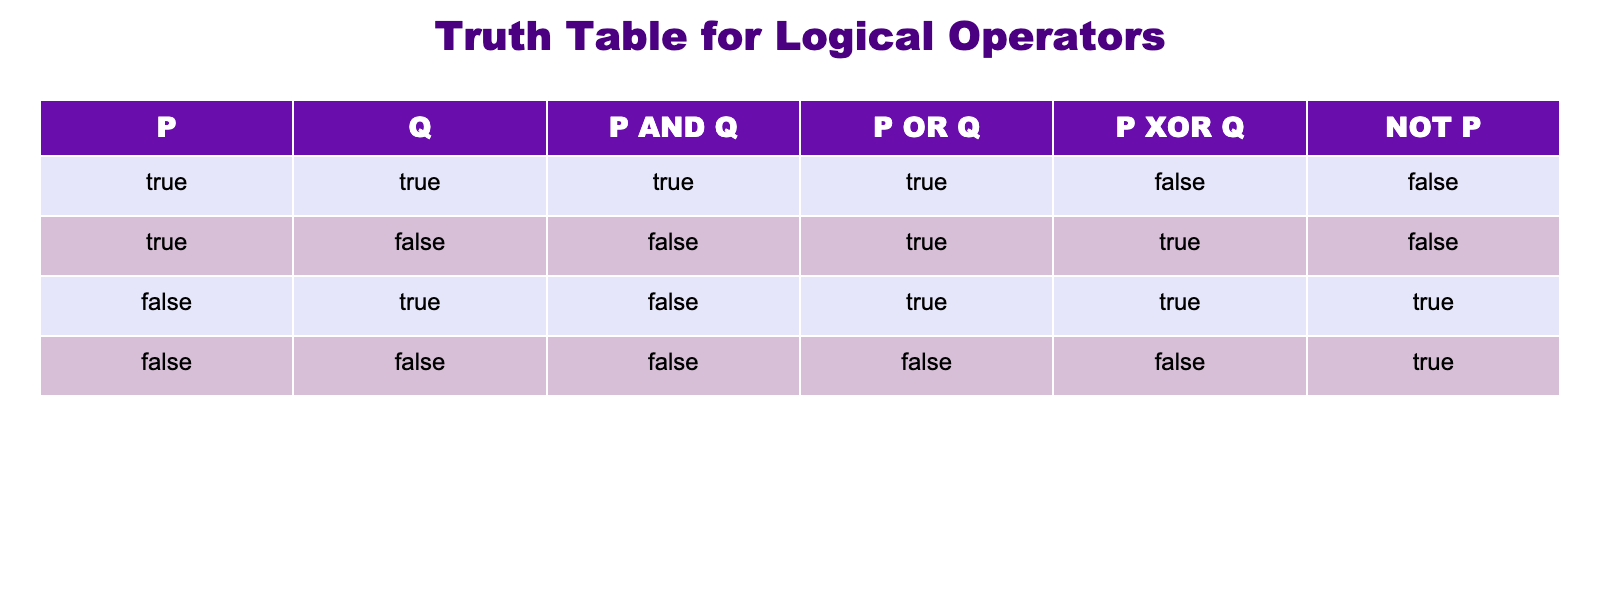What is the value of P AND Q when P is True and Q is False? From the table, we see that when P is True and Q is False, the column for P AND Q shows False. This is because the AND operation only returns True when both operands are True.
Answer: False In how many cases is P OR Q True? By reviewing the P OR Q column across all rows, we find that it is True in three out of the four cases. Specifically, it is True for the rows where Q is False and P is True, where P is False and Q is True, and where both P and Q are True.
Answer: 3 Does NOT P yield True when P is False? According to the NOT P column, when P is False, NOT P is True. The operation NOT simply inverts the value of P.
Answer: Yes What is the result of P XOR Q when both P and Q are True? Looking at the P XOR Q column, when both P and Q are True, the result shows False. The XOR operation only returns True when the operands are different.
Answer: False If both P and Q are False, what is the result of P AND Q? Referring to the table, when both P and Q are False, the P AND Q column indicates False. This follows the rule that AND requires both inputs to be True for the output to be True.
Answer: False What is the total number of scenarios where P XOR Q is True? To determine how many times P XOR Q is True, we can count the True values in the P XOR Q column. We find that it is True in two out of the four scenarios presented in the table.
Answer: 2 Can P OR Q ever be False? A quick examination of the P OR Q column reveals that it is only False when both P and Q are False. Since there is one occurrence of this, we conclude that it can indeed be False.
Answer: Yes How many scenarios produce a True value for NOT P when P is True? Examining the NOT P column, it shows that when P is True, NOT P is False. Therefore, there are no scenarios that yield a True value for NOT P when P is True.
Answer: 0 What are the values of P AND Q, P OR Q, and P XOR Q when P is True and Q is True? Looking at the table, when P is True and Q is True, the values are P AND Q is True, P OR Q is True, and P XOR Q is False. This is consistent with the logical definitions of these operations.
Answer: True, True, False 